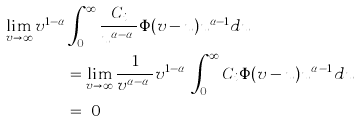<formula> <loc_0><loc_0><loc_500><loc_500>\lim _ { v \to \infty } v ^ { 1 - \alpha } & \int _ { 0 } ^ { \infty } \frac { C _ { i } } { u ^ { \alpha - \alpha _ { i } } } \Phi ( v - u ) u ^ { \alpha - 1 } d u \\ & = \lim _ { v \to \infty } \frac { 1 } { v ^ { \alpha - \alpha _ { i } } } v ^ { 1 - \alpha _ { i } } \int _ { 0 } ^ { \infty } C _ { i } \Phi ( v - u ) u ^ { \alpha _ { i } - 1 } d u \\ & = \ 0</formula> 